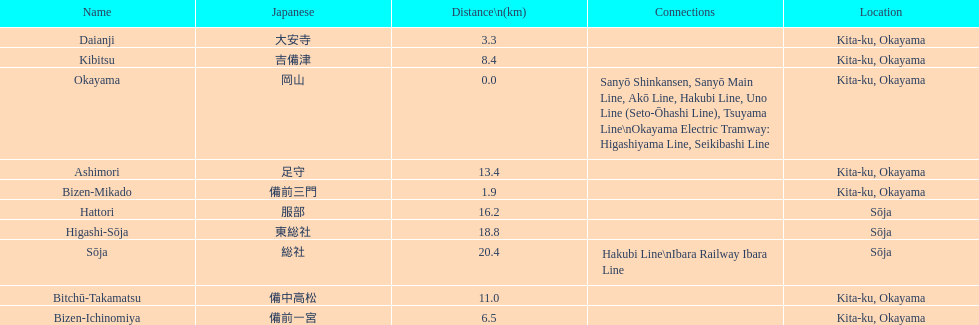How many consecutive stops must you travel through is you board the kibi line at bizen-mikado at depart at kibitsu? 2. 